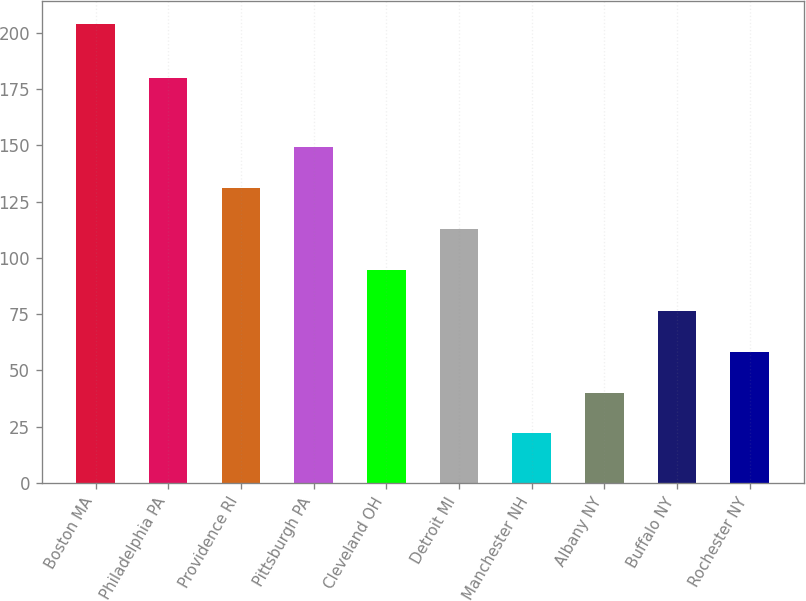Convert chart. <chart><loc_0><loc_0><loc_500><loc_500><bar_chart><fcel>Boston MA<fcel>Philadelphia PA<fcel>Providence RI<fcel>Pittsburgh PA<fcel>Cleveland OH<fcel>Detroit MI<fcel>Manchester NH<fcel>Albany NY<fcel>Buffalo NY<fcel>Rochester NY<nl><fcel>204<fcel>180<fcel>131.2<fcel>149.4<fcel>94.8<fcel>113<fcel>22<fcel>40.2<fcel>76.6<fcel>58.4<nl></chart> 